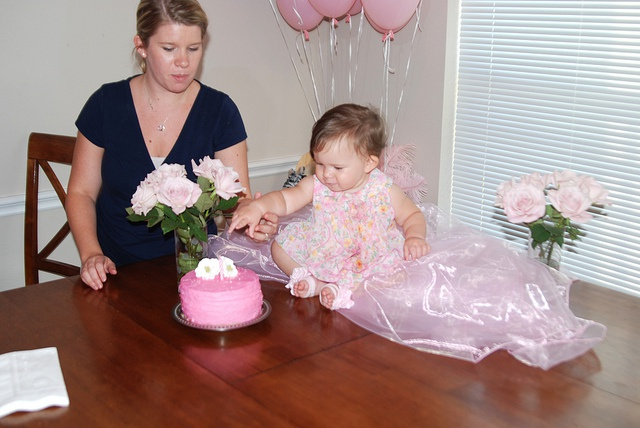Describe the objects in this image and their specific colors. I can see dining table in darkgray, maroon, and brown tones, people in darkgray, black, lightpink, and salmon tones, people in darkgray, lightpink, lightgray, pink, and brown tones, chair in darkgray, maroon, black, and gray tones, and cake in darkgray, lightpink, pink, and violet tones in this image. 